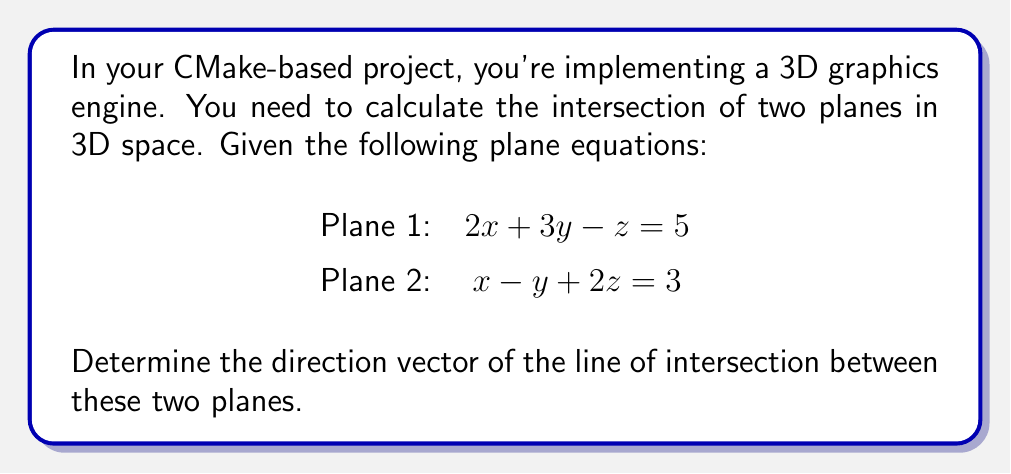Show me your answer to this math problem. To find the direction vector of the line of intersection between two planes, we can follow these steps:

1. Recall that the direction vector of the intersection line is perpendicular to the normal vectors of both planes.

2. The normal vector of Plane 1 is $\vec{n_1} = (2, 3, -1)$.
   The normal vector of Plane 2 is $\vec{n_2} = (1, -1, 2)$.

3. The direction vector of the intersection line can be found by taking the cross product of these normal vectors:

   $$\vec{d} = \vec{n_1} \times \vec{n_2}$$

4. Calculate the cross product:

   $$\begin{vmatrix}
   \hat{i} & \hat{j} & \hat{k} \\
   2 & 3 & -1 \\
   1 & -1 & 2
   \end{vmatrix}$$

   $$= (3 \cdot 2 - (-1) \cdot (-1))\hat{i} - (2 \cdot 2 - (-1) \cdot 1)\hat{j} + (2 \cdot (-1) - 3 \cdot 1)\hat{k}$$

5. Simplify:

   $$\vec{d} = (6 - 1)\hat{i} - (4 + 1)\hat{j} + (-2 - 3)\hat{k}$$
   $$\vec{d} = 5\hat{i} - 5\hat{j} - 5\hat{k}$$

6. The direction vector can be simplified by dividing by the common factor:

   $$\vec{d} = (1, -1, -1)$$

This vector represents the direction of the line of intersection between the two planes.
Answer: $(1, -1, -1)$ 